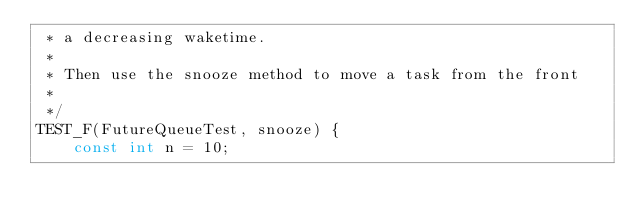<code> <loc_0><loc_0><loc_500><loc_500><_C++_> * a decreasing waketime.
 *
 * Then use the snooze method to move a task from the front
 *
 */
TEST_F(FutureQueueTest, snooze) {
    const int n = 10;
</code> 